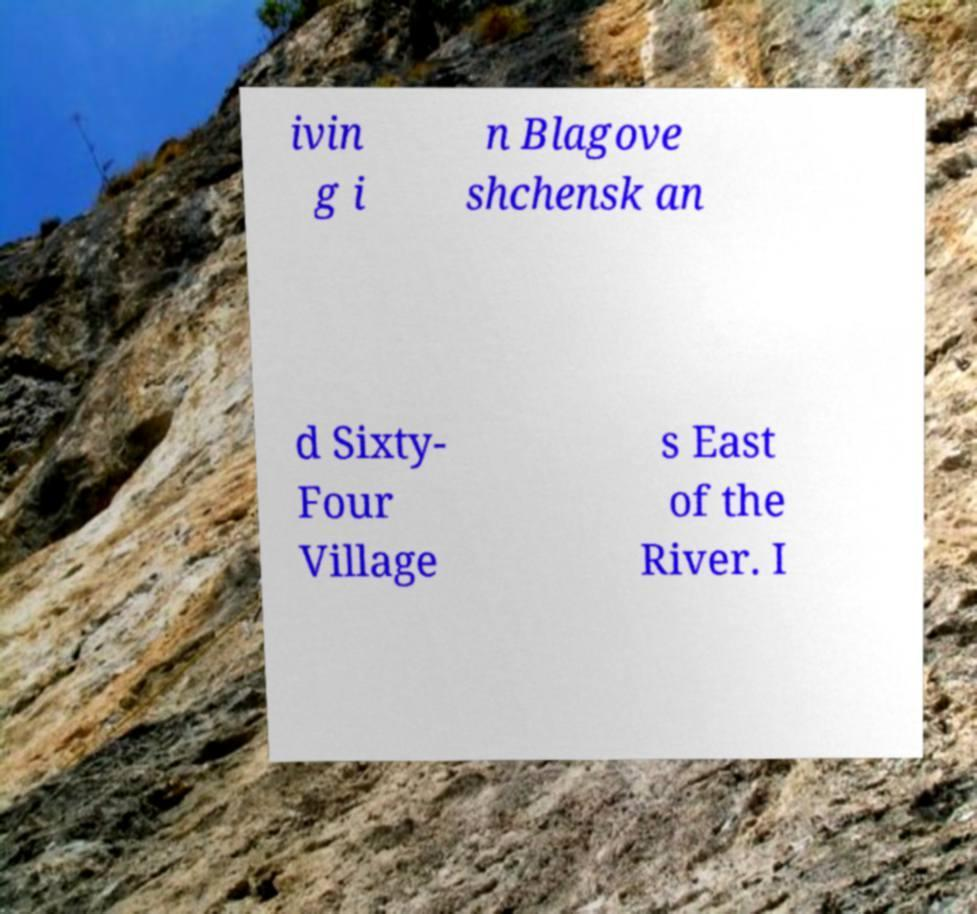There's text embedded in this image that I need extracted. Can you transcribe it verbatim? ivin g i n Blagove shchensk an d Sixty- Four Village s East of the River. I 